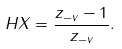<formula> <loc_0><loc_0><loc_500><loc_500>H X = \frac { z _ { - v } - 1 } { z _ { - v } } .</formula> 